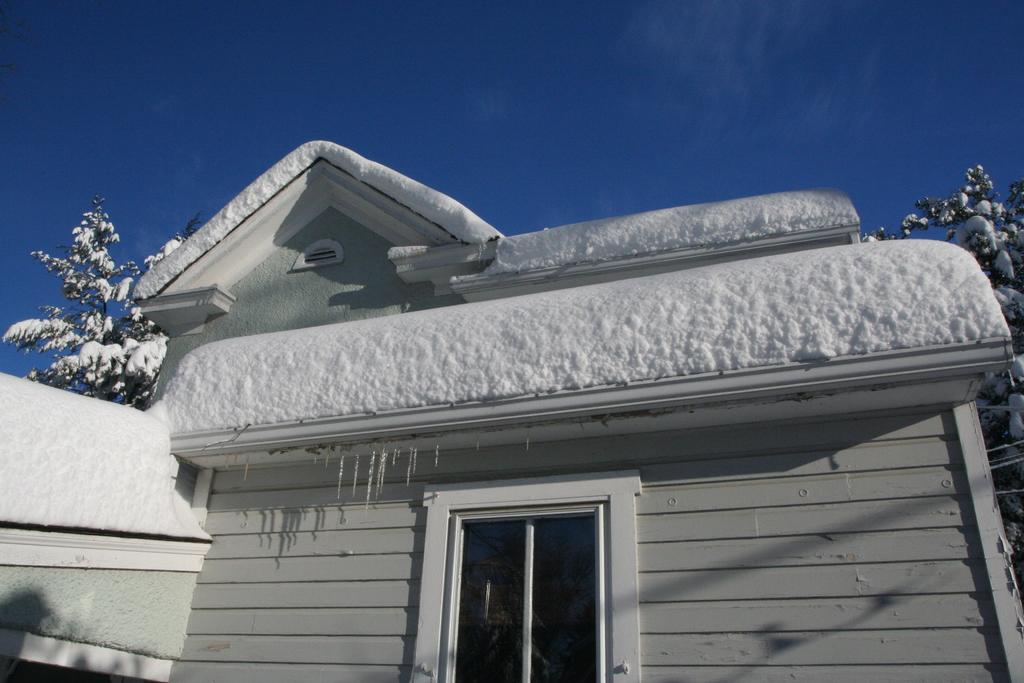What type of structure is present in the image? There is a house in the image. What natural elements can be seen in the image? There are trees in the image. What weather condition is depicted in the image? There is snow visible in the image. How many legs can be seen supporting the house in the image? The image does not show any legs supporting the house; it is a typical house structure. 